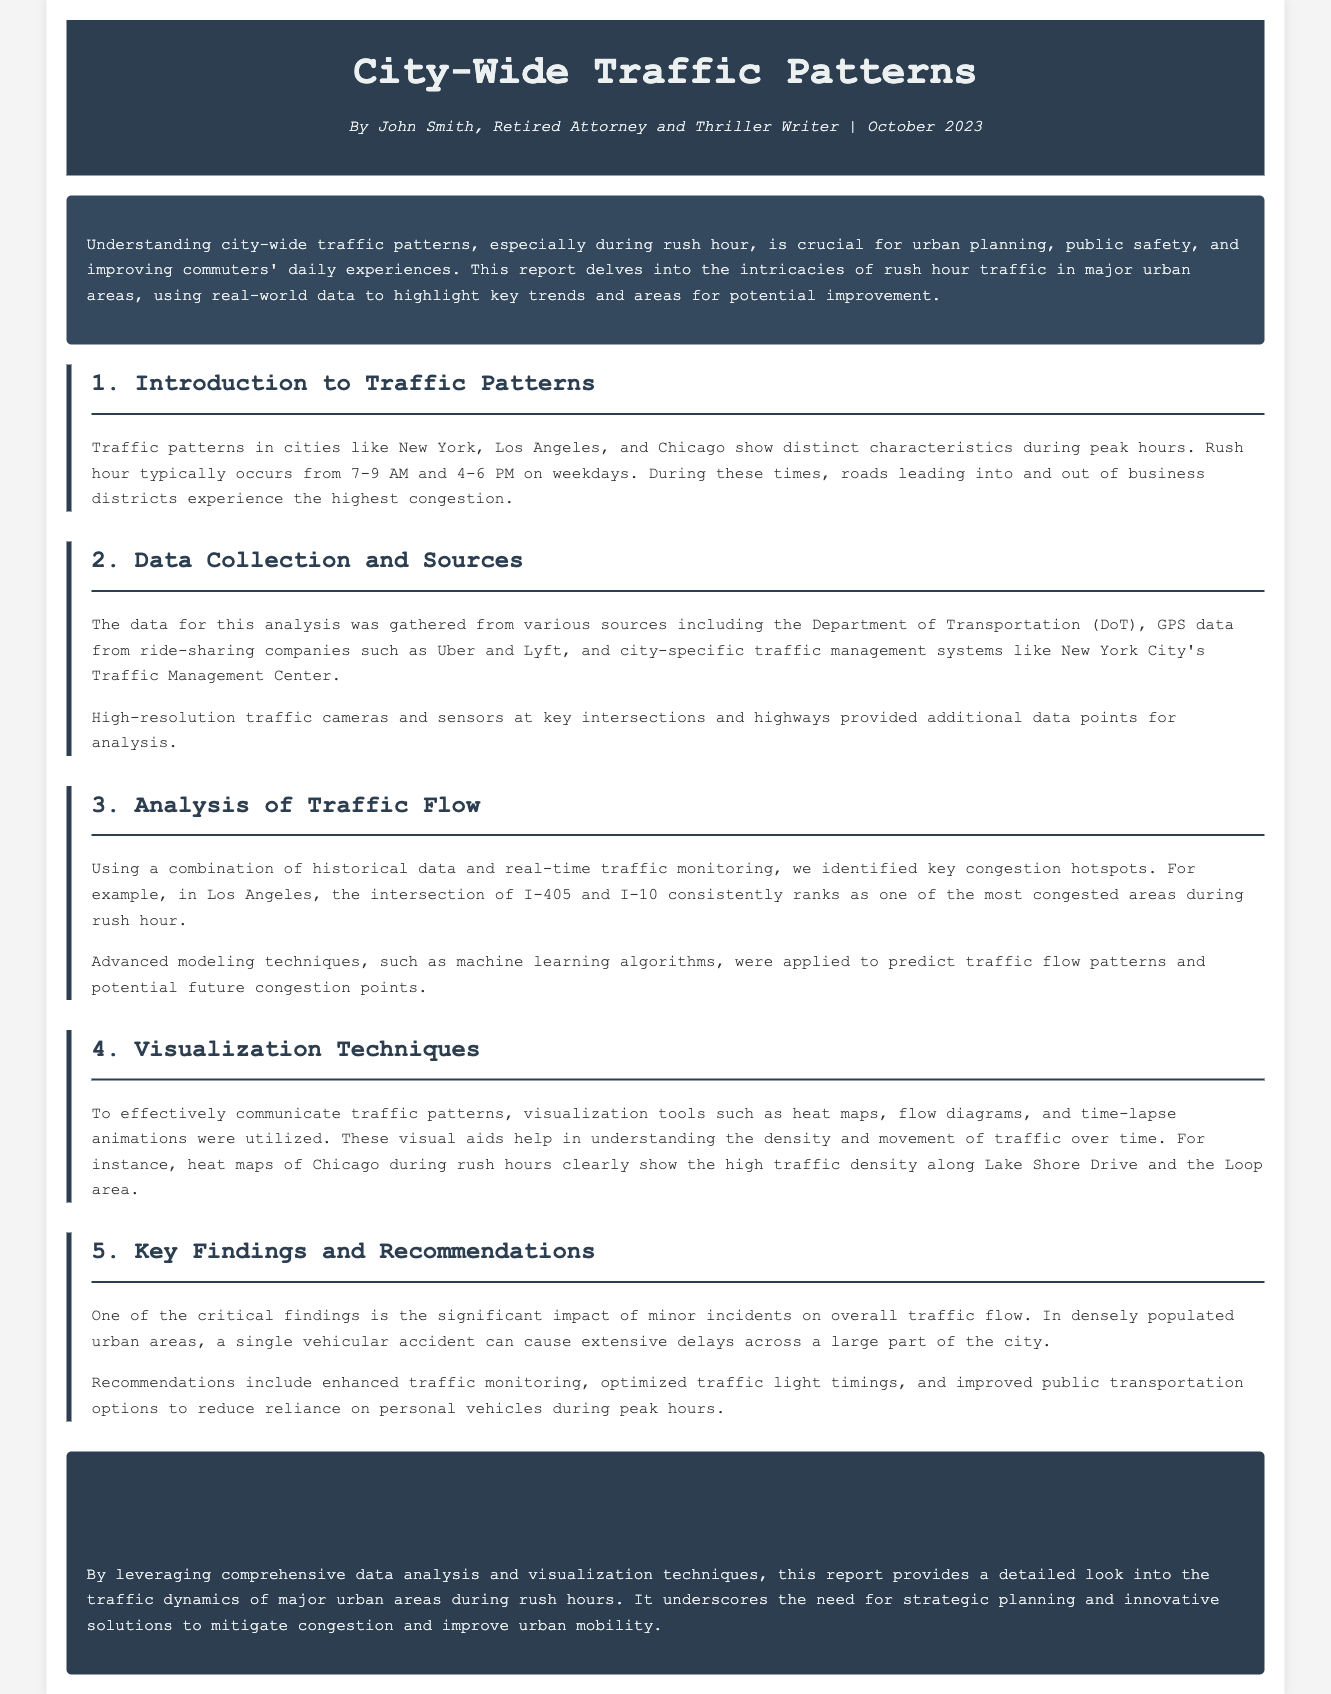What are the peak hours for rush hour traffic? The report states that rush hour typically occurs from 7-9 AM and 4-6 PM on weekdays.
Answer: 7-9 AM and 4-6 PM Which city has the intersection of I-405 and I-10 as a congestion hotspot? The document mentions that this intersection is consistently one of the most congested areas during rush hour in Los Angeles.
Answer: Los Angeles What method was applied to predict traffic flow patterns? The report indicates that advanced modeling techniques, specifically machine learning algorithms, were used for predicting traffic flow patterns.
Answer: Machine learning algorithms What visualization tools were utilized in the report? The report includes heat maps, flow diagrams, and time-lapse animations as visualization tools.
Answer: Heat maps, flow diagrams, time-lapse animations What is a critical finding regarding minor incidents? According to the report, a single vehicular accident can cause extensive delays across a large part of the city.
Answer: Extensive delays What are two recommendations mentioned in the report? The report discusses enhanced traffic monitoring and optimized traffic light timings as key recommendations.
Answer: Enhanced traffic monitoring and optimized traffic light timings 